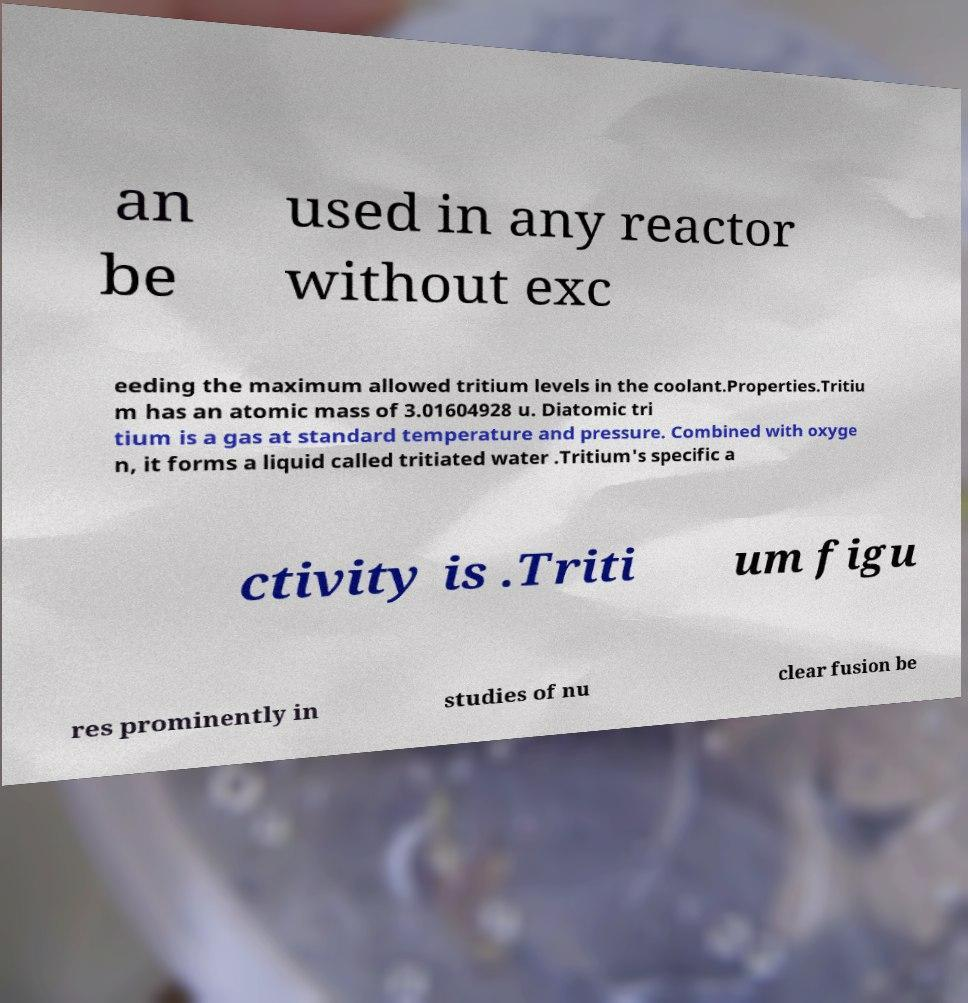Could you assist in decoding the text presented in this image and type it out clearly? an be used in any reactor without exc eeding the maximum allowed tritium levels in the coolant.Properties.Tritiu m has an atomic mass of 3.01604928 u. Diatomic tri tium is a gas at standard temperature and pressure. Combined with oxyge n, it forms a liquid called tritiated water .Tritium's specific a ctivity is .Triti um figu res prominently in studies of nu clear fusion be 